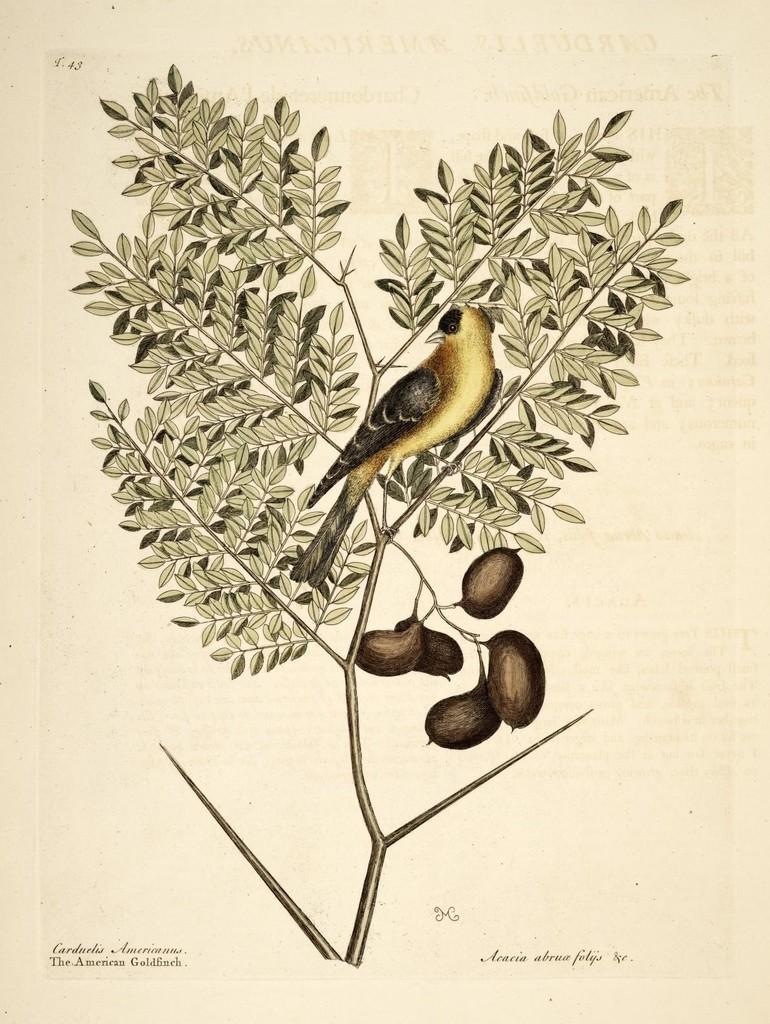How would you summarize this image in a sentence or two? In this picture we can see a bird, leaves and fruits on a plant. There is some text visible at the bottom of the picture. We can see the numbers in the top left. 